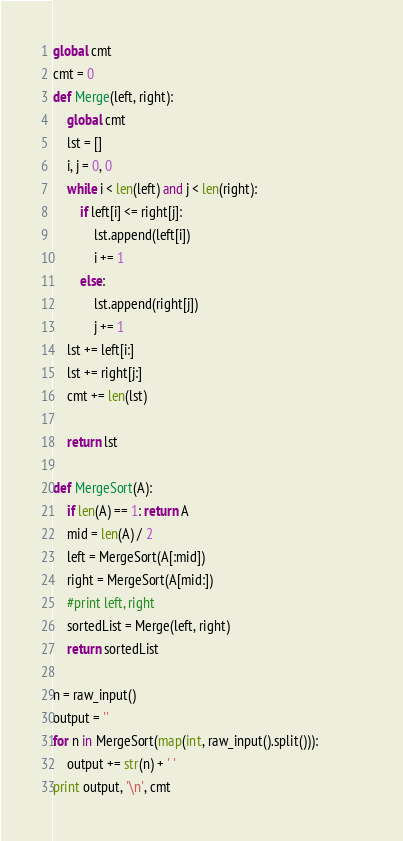<code> <loc_0><loc_0><loc_500><loc_500><_Python_>global cmt                                                     
cmt = 0                                                        
def Merge(left, right):                                        
    global cmt                                                 
    lst = []                                                   
    i, j = 0, 0                                                
    while i < len(left) and j < len(right):                    
        if left[i] <= right[j]:                                
            lst.append(left[i])                                
            i += 1                                             
        else:                                                  
            lst.append(right[j])                               
            j += 1                                             
    lst += left[i:]                                            
    lst += right[j:]                                           
    cmt += len(lst)                                            
                                                               
    return lst                                                 
                                                               
def MergeSort(A):                                              
    if len(A) == 1: return A                                   
    mid = len(A) / 2                                           
    left = MergeSort(A[:mid])                                  
    right = MergeSort(A[mid:])                                 
    #print left, right                                         
    sortedList = Merge(left, right)                            
    return sortedList                                          
                                                               
n = raw_input()                                                
output = ''                                                    
for n in MergeSort(map(int, raw_input().split())):             
    output += str(n) + ' '                                     
print output, '\n', cmt</code> 